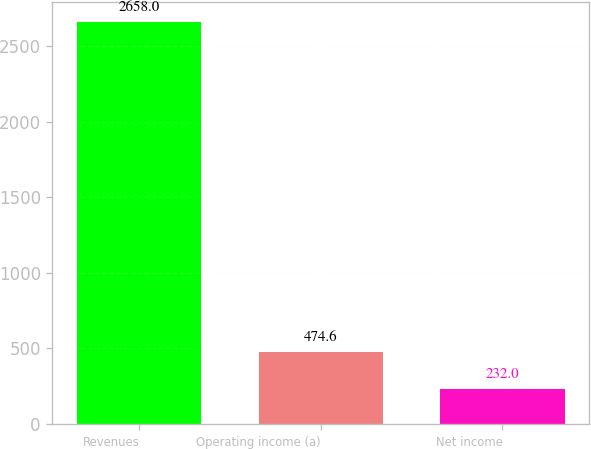Convert chart. <chart><loc_0><loc_0><loc_500><loc_500><bar_chart><fcel>Revenues<fcel>Operating income (a)<fcel>Net income<nl><fcel>2658<fcel>474.6<fcel>232<nl></chart> 